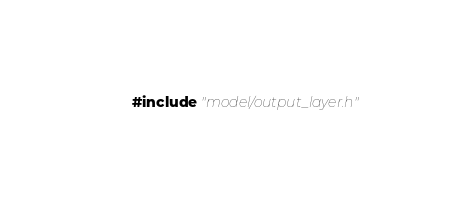Convert code to text. <code><loc_0><loc_0><loc_500><loc_500><_C++_>#include "model/output_layer.h"
</code> 